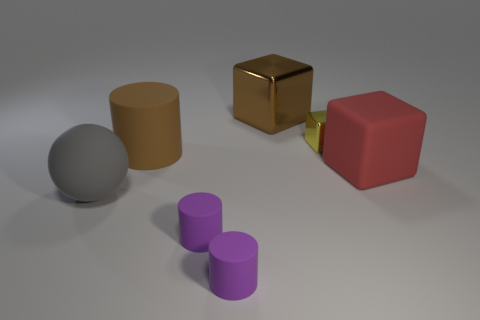Do the big cylinder and the large object that is behind the large matte cylinder have the same color?
Your answer should be very brief. Yes. Do the gray sphere and the cylinder that is behind the rubber ball have the same size?
Offer a terse response. Yes. How many cubes are red metallic things or big gray rubber objects?
Offer a terse response. 0. How many large rubber objects are both on the left side of the large red thing and on the right side of the gray matte ball?
Keep it short and to the point. 1. How many other objects are the same color as the large metallic cube?
Keep it short and to the point. 1. What is the shape of the brown thing behind the small yellow metal object?
Offer a very short reply. Cube. Is the yellow object made of the same material as the brown block?
Provide a succinct answer. Yes. There is a gray matte sphere; what number of tiny yellow things are in front of it?
Provide a succinct answer. 0. What shape is the matte thing that is to the left of the cylinder that is behind the gray matte thing?
Make the answer very short. Sphere. Is there anything else that is the same shape as the gray matte thing?
Keep it short and to the point. No. 